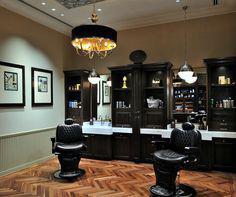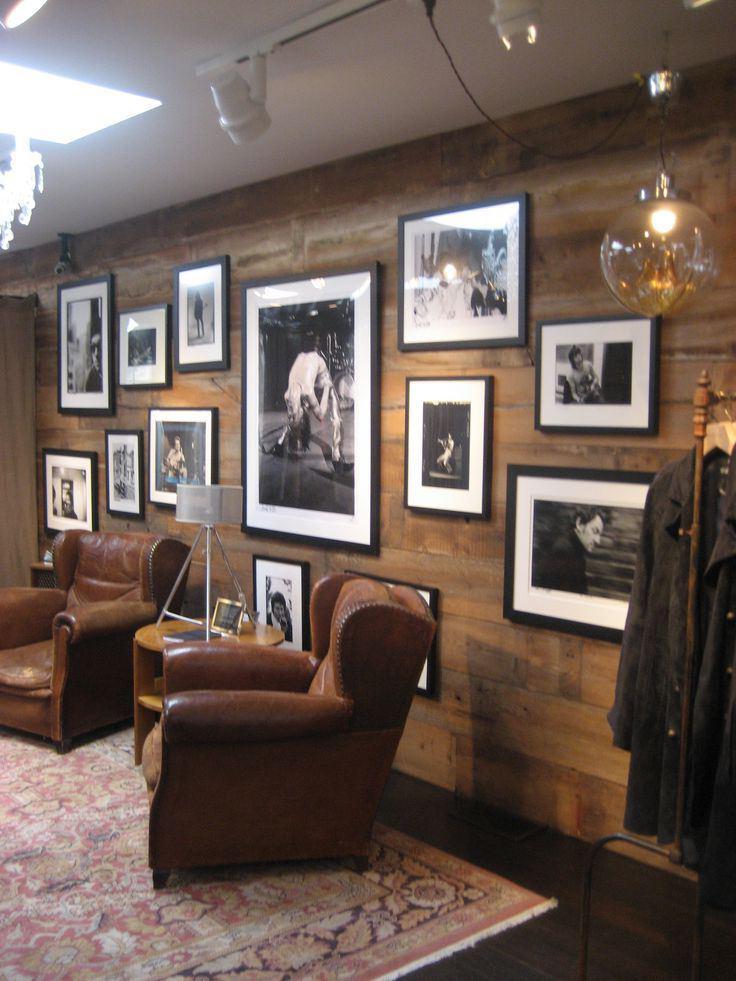The first image is the image on the left, the second image is the image on the right. Given the left and right images, does the statement "The left and right image contains the same number chairs." hold true? Answer yes or no. Yes. The first image is the image on the left, the second image is the image on the right. Examine the images to the left and right. Is the description "The left image features at least one empty back-turned black barber chair in front of a rectangular mirror." accurate? Answer yes or no. No. 